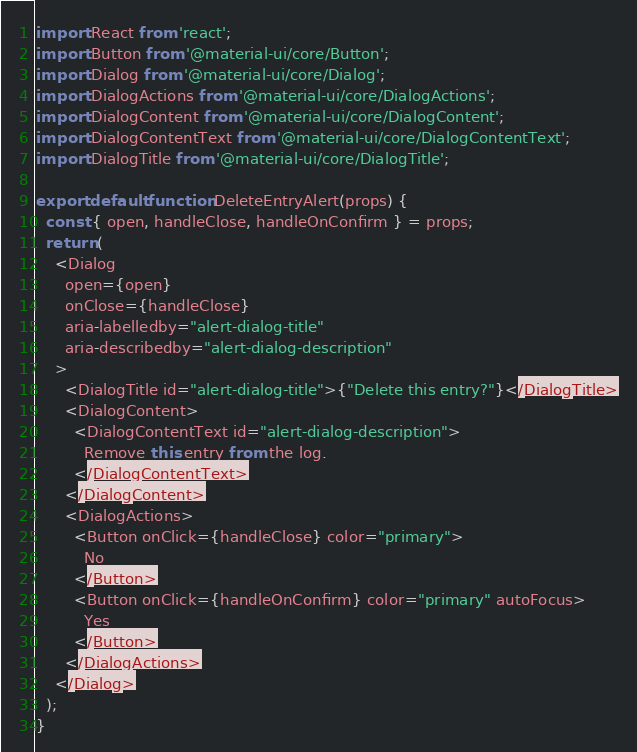Convert code to text. <code><loc_0><loc_0><loc_500><loc_500><_JavaScript_>import React from 'react';
import Button from '@material-ui/core/Button';
import Dialog from '@material-ui/core/Dialog';
import DialogActions from '@material-ui/core/DialogActions';
import DialogContent from '@material-ui/core/DialogContent';
import DialogContentText from '@material-ui/core/DialogContentText';
import DialogTitle from '@material-ui/core/DialogTitle';

export default function DeleteEntryAlert(props) {
  const { open, handleClose, handleOnConfirm } = props;
  return (
    <Dialog
      open={open}
      onClose={handleClose}
      aria-labelledby="alert-dialog-title"
      aria-describedby="alert-dialog-description"
    >
      <DialogTitle id="alert-dialog-title">{"Delete this entry?"}</DialogTitle>
      <DialogContent>
        <DialogContentText id="alert-dialog-description">
          Remove this entry from the log.
        </DialogContentText>
      </DialogContent>
      <DialogActions>
        <Button onClick={handleClose} color="primary">
          No
        </Button>
        <Button onClick={handleOnConfirm} color="primary" autoFocus>
          Yes
        </Button>
      </DialogActions>
    </Dialog>
  );
}
</code> 